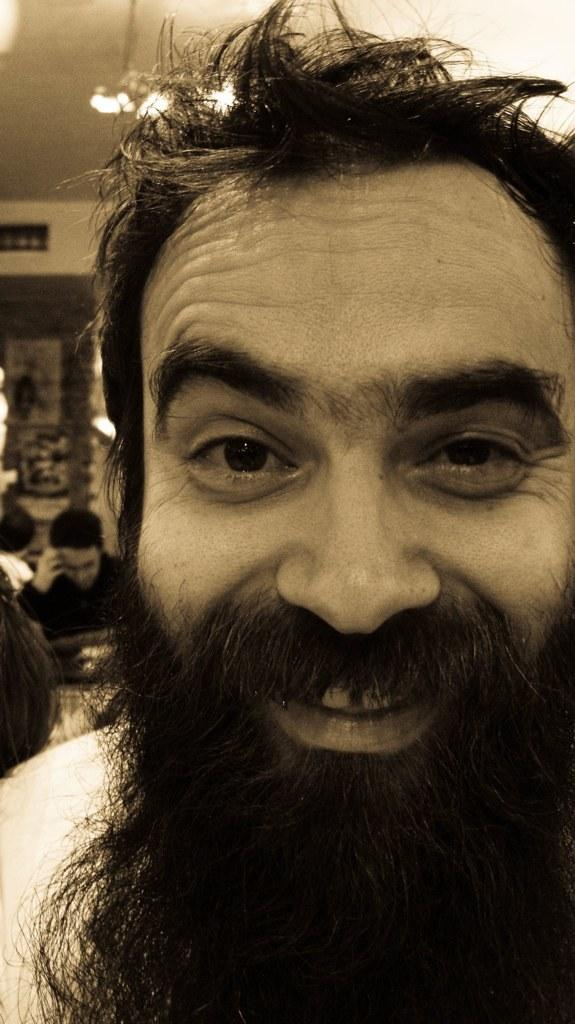What is a distinctive feature of the person in the image? The person in the image has a long beard. What is the color of the person's beard? The beard is black in color. What can be seen in the background of the image? There are other persons, a wall, a ceiling, and lights visible in the background of the image. What type of force is being applied to the drain in the image? There is no drain present in the image, so no force can be applied to it. 